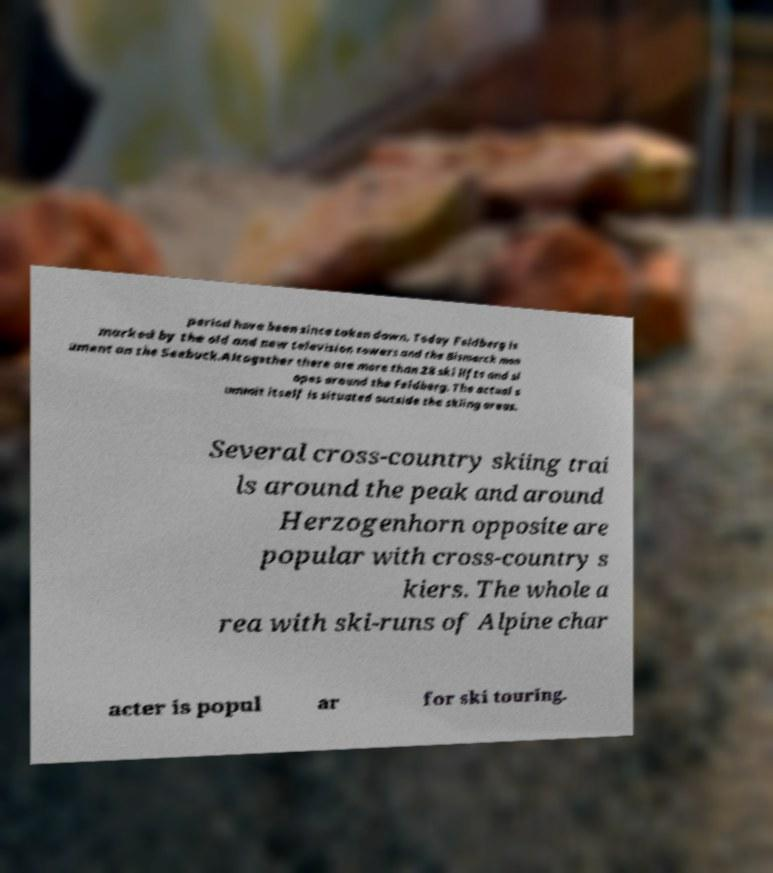Can you accurately transcribe the text from the provided image for me? period have been since taken down. Today Feldberg is marked by the old and new television towers and the Bismarck mon ument on the Seebuck.Altogether there are more than 28 ski lifts and sl opes around the Feldberg. The actual s ummit itself is situated outside the skiing areas. Several cross-country skiing trai ls around the peak and around Herzogenhorn opposite are popular with cross-country s kiers. The whole a rea with ski-runs of Alpine char acter is popul ar for ski touring. 